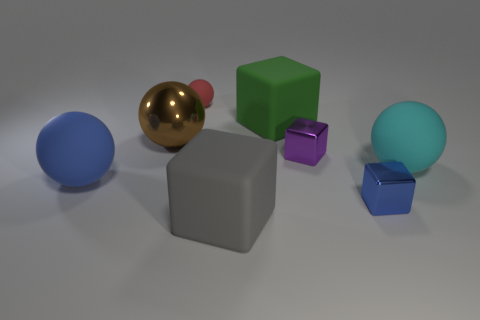Are there the same number of big cyan matte spheres to the right of the big brown ball and cyan things?
Make the answer very short. Yes. There is another large thing that is the same shape as the large green thing; what is its color?
Give a very brief answer. Gray. Do the red matte thing and the purple shiny thing have the same size?
Your answer should be very brief. Yes. Are there the same number of large gray objects in front of the small purple metallic cube and large green blocks that are in front of the shiny sphere?
Give a very brief answer. No. Are any small gray metal balls visible?
Offer a very short reply. No. There is a metallic object that is the same shape as the blue rubber object; what is its size?
Offer a very short reply. Large. There is a rubber cube in front of the big brown sphere; what size is it?
Your answer should be very brief. Large. Are there more big balls to the right of the brown metal sphere than small metal objects?
Provide a short and direct response. No. What is the shape of the small red object?
Offer a very short reply. Sphere. There is a matte sphere right of the red ball; is its color the same as the block that is behind the small purple cube?
Your response must be concise. No. 